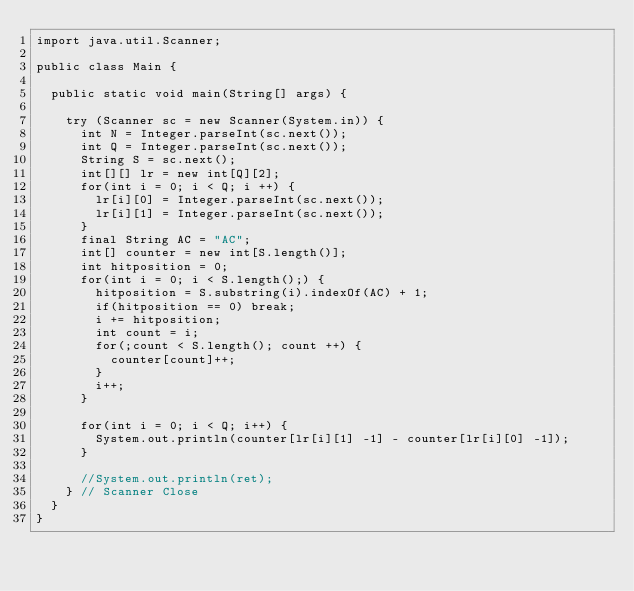<code> <loc_0><loc_0><loc_500><loc_500><_Java_>import java.util.Scanner;

public class Main {
	
	public static void main(String[] args) {

		try (Scanner sc = new Scanner(System.in)) {
			int N = Integer.parseInt(sc.next());
			int Q = Integer.parseInt(sc.next());
			String S = sc.next();
			int[][] lr = new int[Q][2];
			for(int i = 0; i < Q; i ++) {
				lr[i][0] = Integer.parseInt(sc.next());
				lr[i][1] = Integer.parseInt(sc.next());
			}
			final String AC = "AC";
			int[] counter = new int[S.length()];
			int hitposition = 0;
			for(int i = 0; i < S.length();) {
				hitposition = S.substring(i).indexOf(AC) + 1;
				if(hitposition == 0) break;
				i += hitposition;
				int count = i;
				for(;count < S.length(); count ++) {
					counter[count]++;
				}
				i++;
			}
			
			for(int i = 0; i < Q; i++) {
				System.out.println(counter[lr[i][1] -1] - counter[lr[i][0] -1]);
			}
			
			//System.out.println(ret);
		} // Scanner Close
	}
}</code> 